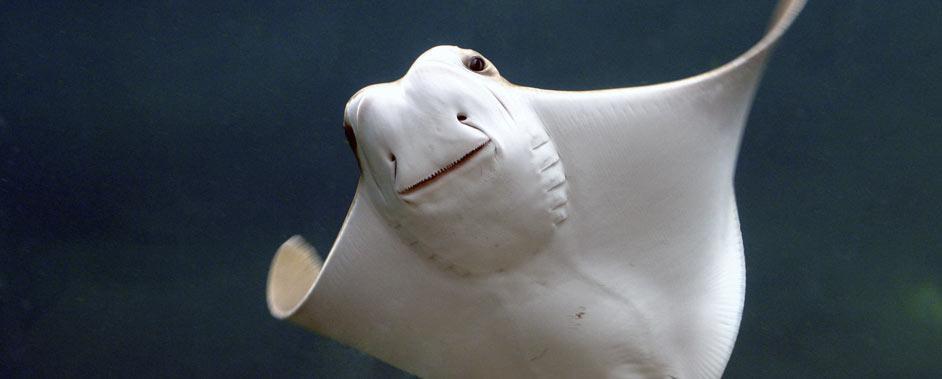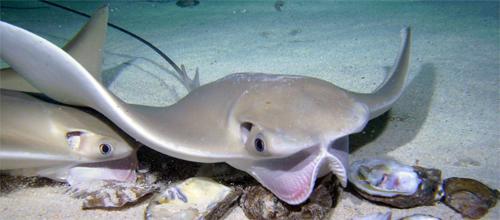The first image is the image on the left, the second image is the image on the right. Assess this claim about the two images: "There are no more than 3 sting rays total.". Correct or not? Answer yes or no. Yes. The first image is the image on the left, the second image is the image on the right. Analyze the images presented: Is the assertion "Has atleast one image with more than 2 stingrays" valid? Answer yes or no. No. 